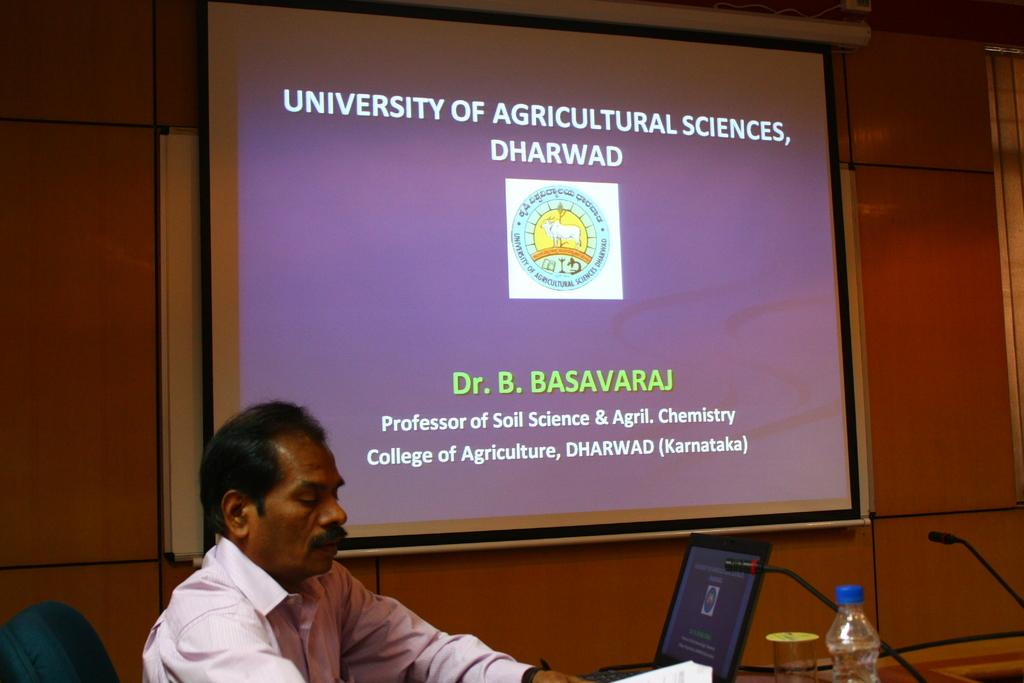Provide a one-sentence caption for the provided image. A teacher sitting in front of a screen where a powerpoint titled University of Agricultural Sciences, Dharwad. 